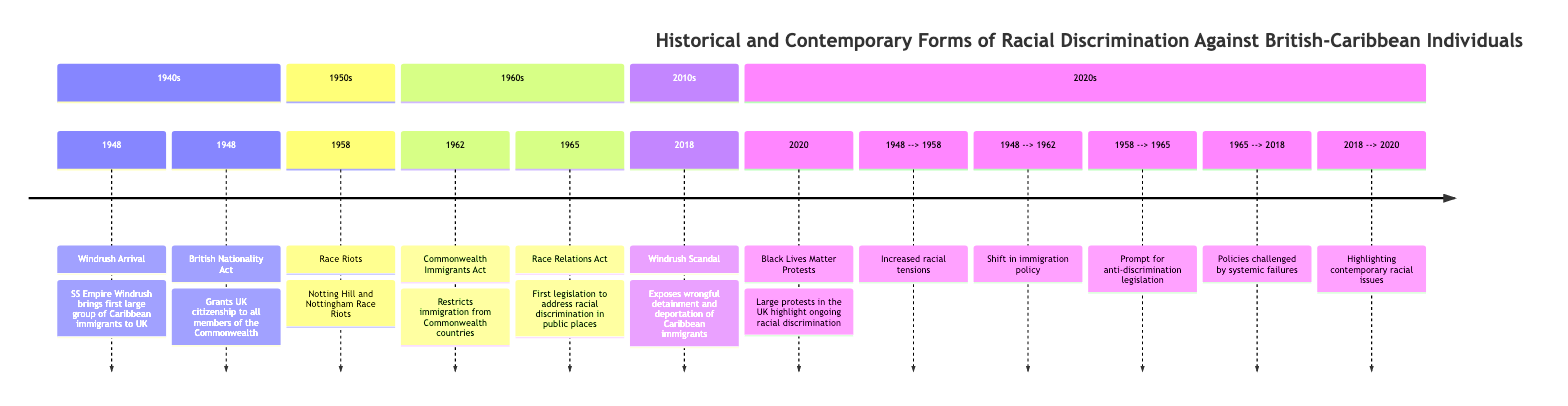What year did the Windrush arrive? The diagram indicates that the SS Empire Windrush brought the first large group of Caribbean immigrants to the UK in 1948. By extracting this specific piece of information, we can directly answer the question.
Answer: 1948 What event occurred in 1958? By examining the 1958 section of the diagram, we find that this year is marked by the Notting Hill and Nottingham Race Riots. This is the key event listed for that year.
Answer: Race Riots How many major events are listed in the 1960s section? The 1960s section of the diagram lists two major events: the Commonwealth Immigrants Act in 1962 and the Race Relations Act in 1965. Counting these, we find there are two events in this section.
Answer: 2 What act was passed in 1965? The diagram shows that in 1965, the Race Relations Act was passed, which was the first legislation to address racial discrimination in public places. This specific act is highlighted in the diagram for that year.
Answer: Race Relations Act What important change did the Windrush Scandal in 2018 highlight? The Windrush Scandal of 2018 brought attention to wrongful detainment and deportation of Caribbean immigrants, showcasing systemic failures in policies over time. This understanding comes from correlating the information in the diagram.
Answer: Systemic failures What did the Race Riots in 1958 prompt? According to the relationships indicated in the diagram, the Race Riots in 1958 prompted the introduction of anti-discrimination legislation, specifically noted in connection with the 1965 Race Relations Act. Thus, they served as a catalyst for legislative change.
Answer: Anti-discrimination legislation Which act restricted immigration from Commonwealth countries? The Commonwealth Immigrants Act of 1962 is clearly stated in the diagram as the act that imposed restrictions on immigration from Commonwealth countries, making it the relevant act for this question.
Answer: Commonwealth Immigrants Act How are the Black Lives Matter Protests of 2020 related to prior events? The diagram connects the 2018 Windrush Scandal to the 2020 Black Lives Matter protests, indicating that the scathing revelations about racial discrimination prompted ongoing protests, thereby emphasizing the continuing relevance of these issues over time.
Answer: Highlighting contemporary racial issues 